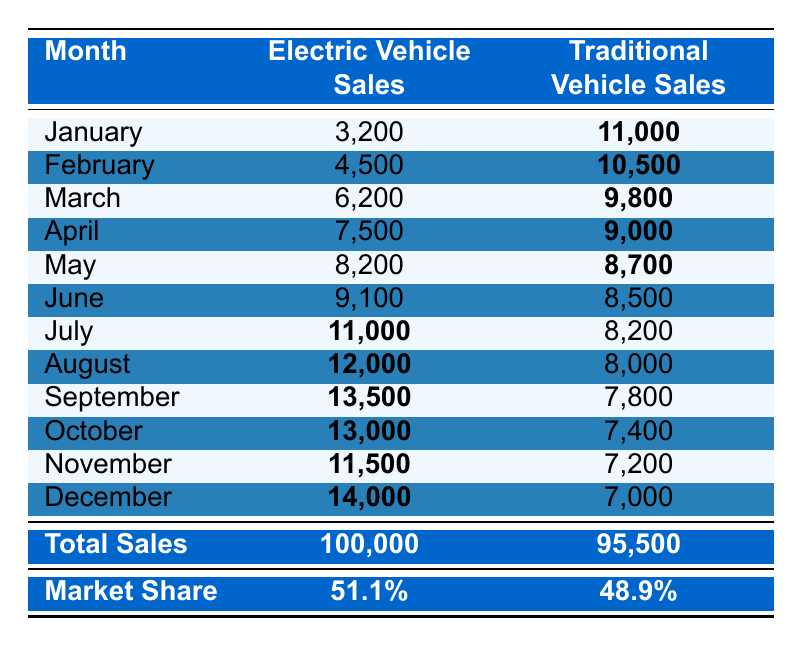What is the total number of electric vehicle sales in 2023? The total electric vehicle sales for the year is provided in the "Total Sales" section, which states 100,000.
Answer: 100,000 What is the traditional vehicle sales in October? The table explicitly lists the traditional vehicle sales for October as 7,400 in the corresponding row.
Answer: 7,400 In which month did electric vehicle sales exceed traditional vehicle sales for the first time? By examining the months sequentially in the table, electric vehicle sales surpassed traditional vehicle sales in July, where electric vehicle sales were 11,000 and traditional vehicle sales were 8,200.
Answer: July What was the percentage market share of electric vehicles? The market share section indicates that electric vehicles constituted 51.1% of the total sales, as shown in the corresponding row.
Answer: 51.1% How many more electric vehicles were sold than traditional vehicles in December? In December, electric vehicle sales were 14,000 and traditional vehicle sales were 7,000. The difference is 14,000 - 7,000 = 7,000.
Answer: 7,000 What is the average electric vehicle sales over the entire year? The total electric vehicle sales of 100,000 divided by 12 months gives an average of 100,000 / 12 ≈ 8,333.33, which can be approximated to 8,333 when considering whole vehicles.
Answer: 8,333 Were traditional vehicle sales lower than 8,000 in any month? Looking through the traditional vehicle sales figures month by month, they were below 8,000 in August, September, October, November, and December, which indicates that there were indeed months where the sales were lower.
Answer: Yes What was the difference in sales between electric vehicles and traditional vehicles for the month with the highest sales? The month with the highest electric vehicle sales is December (14,000) and the corresponding traditional vehicle sales that month are 7,000. The difference is 14,000 - 7,000 = 7,000.
Answer: 7,000 What was the total traditional vehicle sales for the first half of the year (January to June)? Summing the traditional vehicle sales from January (11,000), February (10,500), March (9,800), April (9,000), May (8,700), and June (8,500) gives us 11,000 + 10,500 + 9,800 + 9,000 + 8,700 + 8,500 = 57,500.
Answer: 57,500 Was there a month where electric vehicle sales were lower than traditional vehicle sales? Observing the data for each month, electric vehicle sales were lower than traditional vehicle sales in January through June, confirming that this was indeed the case during those months.
Answer: Yes 